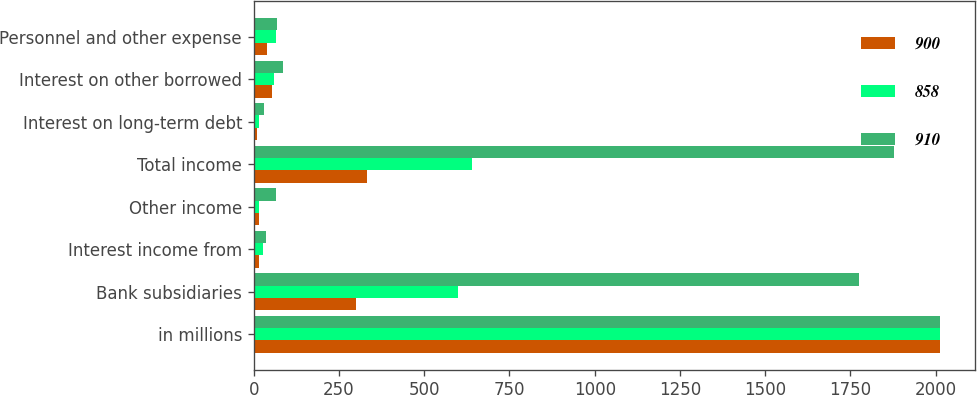Convert chart to OTSL. <chart><loc_0><loc_0><loc_500><loc_500><stacked_bar_chart><ecel><fcel>in millions<fcel>Bank subsidiaries<fcel>Interest income from<fcel>Other income<fcel>Total income<fcel>Interest on long-term debt<fcel>Interest on other borrowed<fcel>Personnel and other expense<nl><fcel>900<fcel>2014<fcel>300<fcel>16<fcel>15<fcel>331<fcel>10<fcel>53<fcel>40<nl><fcel>858<fcel>2013<fcel>600<fcel>26<fcel>15<fcel>641<fcel>14<fcel>59<fcel>65<nl><fcel>910<fcel>2012<fcel>1775<fcel>36<fcel>66<fcel>1877<fcel>29<fcel>86<fcel>68<nl></chart> 